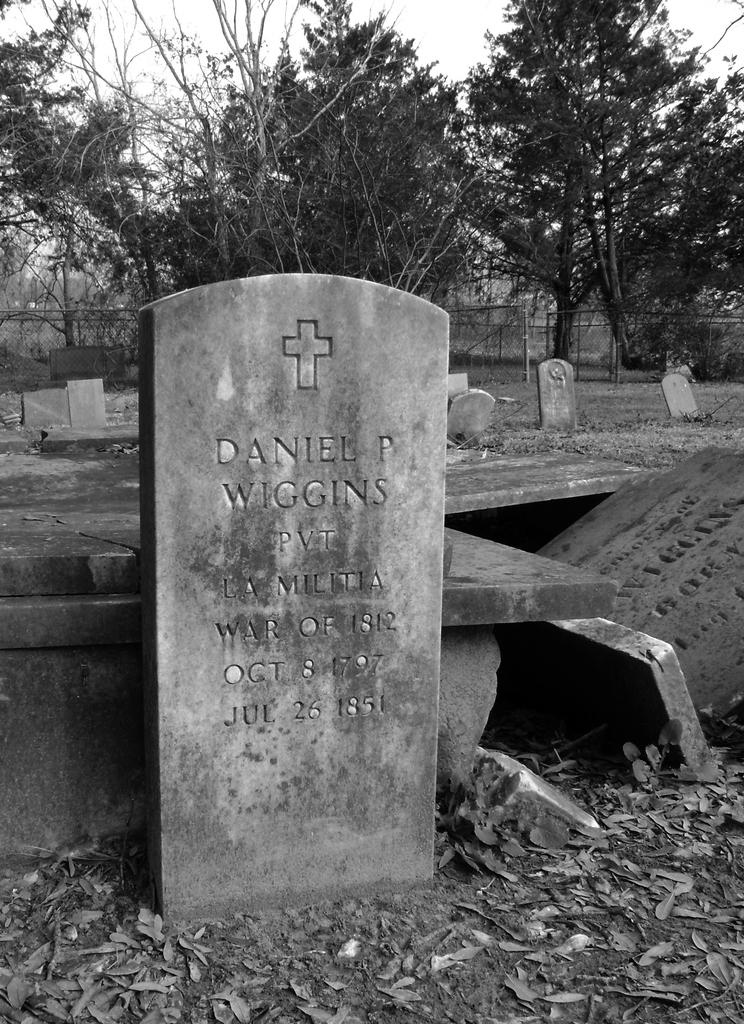What type of location is depicted in the image? The image contains cemeteries. What can be seen in the background of the image? There are trees in the image. What type of barrier is present in the image? There is net fencing in the image. What color scheme is used in the image? The image is in black and white. How many mice can be seen running around in the image? There are no mice present in the image. What type of sock is visible on the tree in the image? There is no sock present in the image; it features cemeteries, trees, and net fencing. 